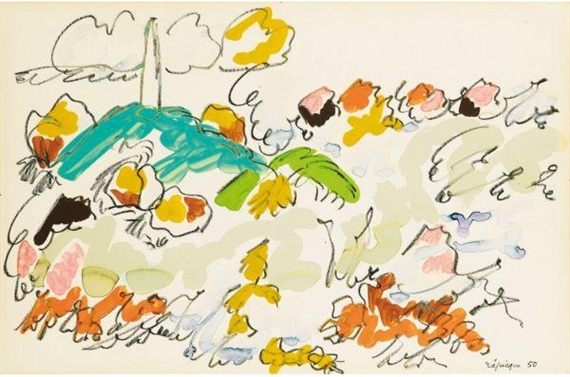Imagine if this artwork was a portal to another dimension. What would the journey through it entail? Stepping through this artwork as a portal would be like diving into a living, breathing work of art. You would find yourself in a dimension where the laws of nature are both whimsical and surreal. The sky would be an endless canvas of shifting colors, and you would float through clouds that change shape with your thoughts. As you move, the ground beneath you would transform into a mosaic of flowers and plants that respond to your emotions. Every step would reveal new, abstract forms that morph and evolve. You might encounter creature-like lines that twist and turn, creating paths that guide you through this fantastical world. It's a journey of endless discovery, where imagination and reality blend seamlessly, and each corner holds a new wonder waiting to be explored. 